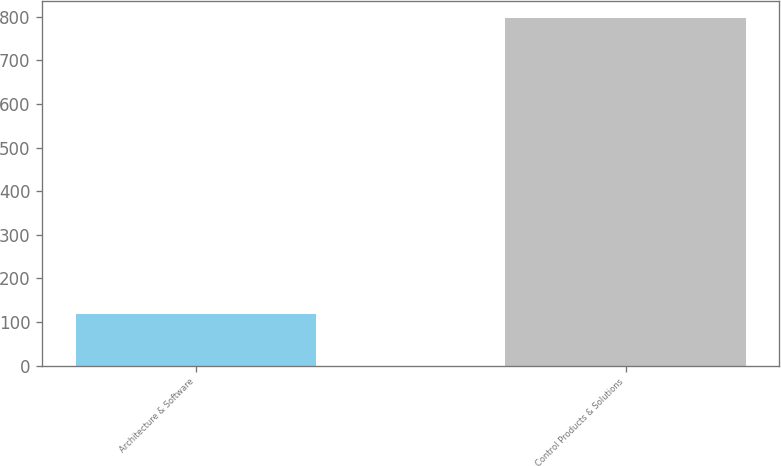<chart> <loc_0><loc_0><loc_500><loc_500><bar_chart><fcel>Architecture & Software<fcel>Control Products & Solutions<nl><fcel>119<fcel>796.7<nl></chart> 